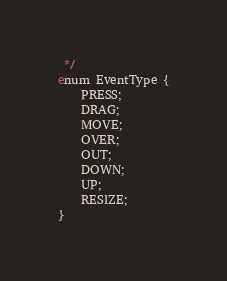Convert code to text. <code><loc_0><loc_0><loc_500><loc_500><_Haxe_> */
enum EventType {
    PRESS;
    DRAG;
    MOVE;
    OVER;
    OUT;
    DOWN;
    UP;
    RESIZE;
}</code> 